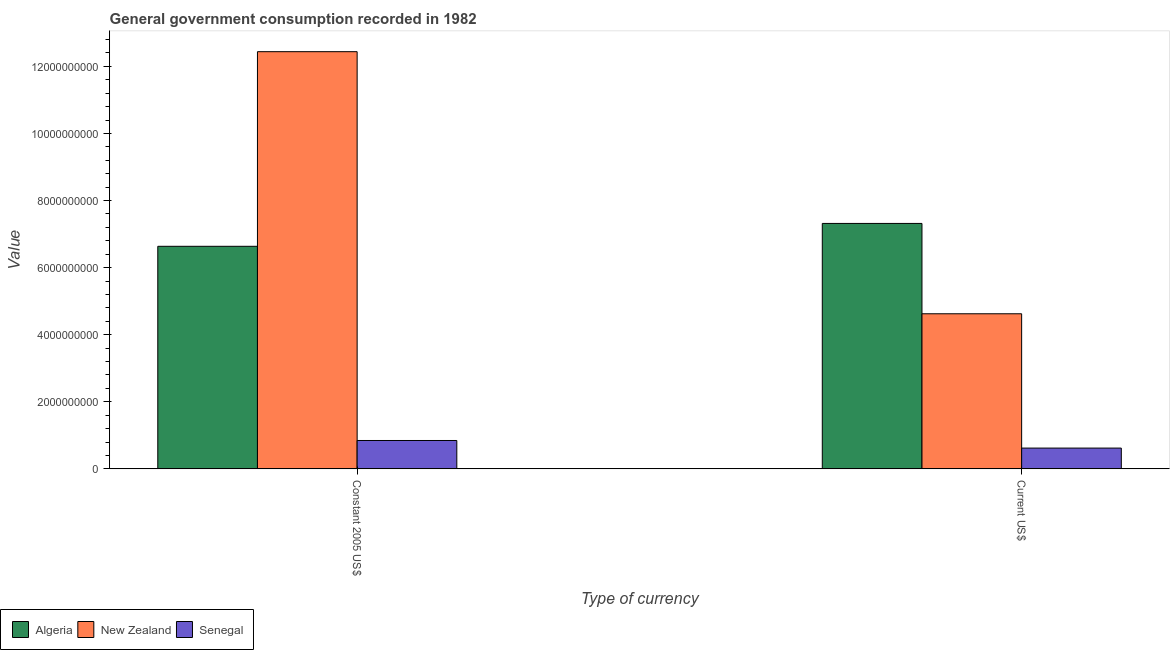How many different coloured bars are there?
Your response must be concise. 3. Are the number of bars on each tick of the X-axis equal?
Your answer should be very brief. Yes. How many bars are there on the 2nd tick from the left?
Keep it short and to the point. 3. How many bars are there on the 2nd tick from the right?
Make the answer very short. 3. What is the label of the 1st group of bars from the left?
Offer a very short reply. Constant 2005 US$. What is the value consumed in constant 2005 us$ in Senegal?
Make the answer very short. 8.45e+08. Across all countries, what is the maximum value consumed in constant 2005 us$?
Offer a terse response. 1.24e+1. Across all countries, what is the minimum value consumed in constant 2005 us$?
Make the answer very short. 8.45e+08. In which country was the value consumed in constant 2005 us$ maximum?
Offer a terse response. New Zealand. In which country was the value consumed in constant 2005 us$ minimum?
Your answer should be very brief. Senegal. What is the total value consumed in constant 2005 us$ in the graph?
Give a very brief answer. 1.99e+1. What is the difference between the value consumed in current us$ in Senegal and that in Algeria?
Give a very brief answer. -6.70e+09. What is the difference between the value consumed in constant 2005 us$ in New Zealand and the value consumed in current us$ in Algeria?
Keep it short and to the point. 5.12e+09. What is the average value consumed in constant 2005 us$ per country?
Provide a short and direct response. 6.64e+09. What is the difference between the value consumed in constant 2005 us$ and value consumed in current us$ in Algeria?
Offer a terse response. -6.82e+08. In how many countries, is the value consumed in current us$ greater than 2000000000 ?
Offer a terse response. 2. What is the ratio of the value consumed in current us$ in New Zealand to that in Algeria?
Your answer should be very brief. 0.63. In how many countries, is the value consumed in constant 2005 us$ greater than the average value consumed in constant 2005 us$ taken over all countries?
Ensure brevity in your answer.  1. What does the 2nd bar from the left in Constant 2005 US$ represents?
Your answer should be very brief. New Zealand. What does the 2nd bar from the right in Current US$ represents?
Keep it short and to the point. New Zealand. How many bars are there?
Give a very brief answer. 6. Are all the bars in the graph horizontal?
Your answer should be compact. No. Does the graph contain any zero values?
Your response must be concise. No. Where does the legend appear in the graph?
Provide a succinct answer. Bottom left. How many legend labels are there?
Provide a succinct answer. 3. How are the legend labels stacked?
Provide a succinct answer. Horizontal. What is the title of the graph?
Your answer should be very brief. General government consumption recorded in 1982. Does "High income: nonOECD" appear as one of the legend labels in the graph?
Make the answer very short. No. What is the label or title of the X-axis?
Make the answer very short. Type of currency. What is the label or title of the Y-axis?
Offer a very short reply. Value. What is the Value of Algeria in Constant 2005 US$?
Ensure brevity in your answer.  6.63e+09. What is the Value in New Zealand in Constant 2005 US$?
Give a very brief answer. 1.24e+1. What is the Value of Senegal in Constant 2005 US$?
Give a very brief answer. 8.45e+08. What is the Value in Algeria in Current US$?
Provide a short and direct response. 7.32e+09. What is the Value of New Zealand in Current US$?
Keep it short and to the point. 4.62e+09. What is the Value in Senegal in Current US$?
Make the answer very short. 6.19e+08. Across all Type of currency, what is the maximum Value of Algeria?
Offer a very short reply. 7.32e+09. Across all Type of currency, what is the maximum Value in New Zealand?
Your response must be concise. 1.24e+1. Across all Type of currency, what is the maximum Value in Senegal?
Provide a succinct answer. 8.45e+08. Across all Type of currency, what is the minimum Value of Algeria?
Offer a very short reply. 6.63e+09. Across all Type of currency, what is the minimum Value in New Zealand?
Keep it short and to the point. 4.62e+09. Across all Type of currency, what is the minimum Value in Senegal?
Your response must be concise. 6.19e+08. What is the total Value in Algeria in the graph?
Provide a succinct answer. 1.40e+1. What is the total Value of New Zealand in the graph?
Ensure brevity in your answer.  1.71e+1. What is the total Value in Senegal in the graph?
Make the answer very short. 1.46e+09. What is the difference between the Value of Algeria in Constant 2005 US$ and that in Current US$?
Your answer should be very brief. -6.82e+08. What is the difference between the Value of New Zealand in Constant 2005 US$ and that in Current US$?
Make the answer very short. 7.81e+09. What is the difference between the Value of Senegal in Constant 2005 US$ and that in Current US$?
Offer a terse response. 2.26e+08. What is the difference between the Value in Algeria in Constant 2005 US$ and the Value in New Zealand in Current US$?
Keep it short and to the point. 2.01e+09. What is the difference between the Value of Algeria in Constant 2005 US$ and the Value of Senegal in Current US$?
Provide a short and direct response. 6.02e+09. What is the difference between the Value in New Zealand in Constant 2005 US$ and the Value in Senegal in Current US$?
Your answer should be compact. 1.18e+1. What is the average Value of Algeria per Type of currency?
Provide a succinct answer. 6.98e+09. What is the average Value in New Zealand per Type of currency?
Ensure brevity in your answer.  8.53e+09. What is the average Value in Senegal per Type of currency?
Your response must be concise. 7.32e+08. What is the difference between the Value in Algeria and Value in New Zealand in Constant 2005 US$?
Give a very brief answer. -5.80e+09. What is the difference between the Value in Algeria and Value in Senegal in Constant 2005 US$?
Provide a succinct answer. 5.79e+09. What is the difference between the Value of New Zealand and Value of Senegal in Constant 2005 US$?
Give a very brief answer. 1.16e+1. What is the difference between the Value of Algeria and Value of New Zealand in Current US$?
Ensure brevity in your answer.  2.69e+09. What is the difference between the Value in Algeria and Value in Senegal in Current US$?
Make the answer very short. 6.70e+09. What is the difference between the Value in New Zealand and Value in Senegal in Current US$?
Provide a short and direct response. 4.00e+09. What is the ratio of the Value in Algeria in Constant 2005 US$ to that in Current US$?
Keep it short and to the point. 0.91. What is the ratio of the Value in New Zealand in Constant 2005 US$ to that in Current US$?
Provide a succinct answer. 2.69. What is the ratio of the Value in Senegal in Constant 2005 US$ to that in Current US$?
Ensure brevity in your answer.  1.37. What is the difference between the highest and the second highest Value in Algeria?
Provide a succinct answer. 6.82e+08. What is the difference between the highest and the second highest Value in New Zealand?
Ensure brevity in your answer.  7.81e+09. What is the difference between the highest and the second highest Value of Senegal?
Offer a very short reply. 2.26e+08. What is the difference between the highest and the lowest Value of Algeria?
Your response must be concise. 6.82e+08. What is the difference between the highest and the lowest Value of New Zealand?
Your response must be concise. 7.81e+09. What is the difference between the highest and the lowest Value in Senegal?
Ensure brevity in your answer.  2.26e+08. 